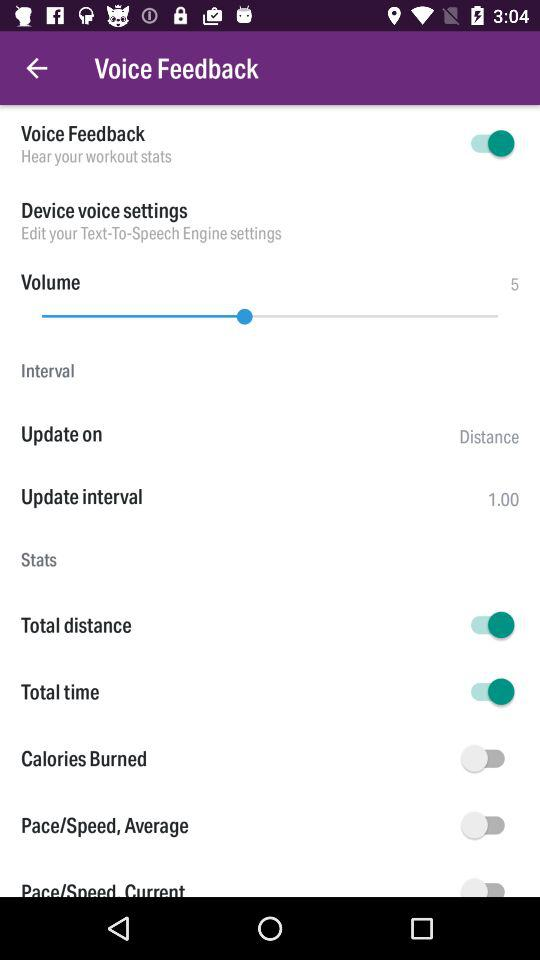What's the "Device voice settings"? The setting is "Edit your Text-To-Speech Engine settings". 